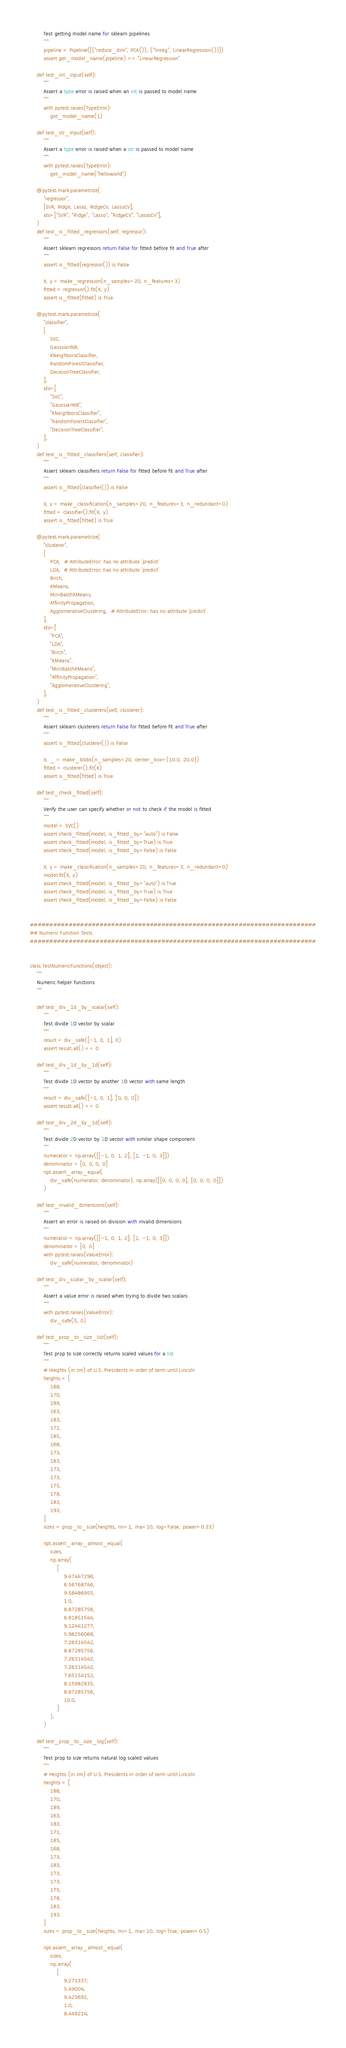<code> <loc_0><loc_0><loc_500><loc_500><_Python_>        Test getting model name for sklearn pipelines
        """
        pipeline = Pipeline([("reduce_dim", PCA()), ("linreg", LinearRegression())])
        assert get_model_name(pipeline) == "LinearRegression"

    def test_int_input(self):
        """
        Assert a type error is raised when an int is passed to model name
        """
        with pytest.raises(TypeError):
            get_model_name(1)

    def test_str_input(self):
        """
        Assert a type error is raised when a str is passed to model name
        """
        with pytest.raises(TypeError):
            get_model_name("helloworld")

    @pytest.mark.parametrize(
        "regressor",
        [SVR, Ridge, Lasso, RidgeCV, LassoCV],
        ids=["SVR", "Ridge", "Lasso", "RidgeCV", "LassoCV"],
    )
    def test_is_fitted_regressors(self, regressor):
        """
        Assert sklearn regressors return False for fitted before fit and True after
        """
        assert is_fitted(regressor()) is False

        X, y = make_regression(n_samples=20, n_features=3)
        fitted = regressor().fit(X, y)
        assert is_fitted(fitted) is True

    @pytest.mark.parametrize(
        "classifier",
        [
            SVC,
            GaussianNB,
            KNeighborsClassifier,
            RandomForestClassifier,
            DecisionTreeClassifier,
        ],
        ids=[
            "SVC",
            "GaussianNB",
            "KNeighborsClassifier",
            "RandomForestClassifier",
            "DecisionTreeClassifier",
        ],
    )
    def test_is_fitted_classifiers(self, classifier):
        """
        Assert sklearn classifiers return False for fitted before fit and True after
        """
        assert is_fitted(classifier()) is False

        X, y = make_classification(n_samples=20, n_features=3, n_redundant=0)
        fitted = classifier().fit(X, y)
        assert is_fitted(fitted) is True

    @pytest.mark.parametrize(
        "clusterer",
        [
            PCA,  # AttributeError: has no attribute 'predict'
            LDA,  # AttributeError: has no attribute 'predict'
            Birch,
            KMeans,
            MiniBatchKMeans,
            AffinityPropagation,
            AgglomerativeClustering,  # AttributeError: has no attribute 'predict'
        ],
        ids=[
            "PCA",
            "LDA",
            "Birch",
            "KMeans",
            "MiniBatchKMeans",
            "AffinityPropagation",
            "AgglomerativeClustering",
        ],
    )
    def test_is_fitted_clusterers(self, clusterer):
        """
        Assert sklearn clusterers return False for fitted before fit and True after
        """
        assert is_fitted(clusterer()) is False

        X, _ = make_blobs(n_samples=20, center_box=(10.0, 20.0))
        fitted = clusterer().fit(X)
        assert is_fitted(fitted) is True

    def test_check_fitted(self):
        """
        Verify the user can specify whether or not to check if the model is fitted
        """
        model = SVC()
        assert check_fitted(model, is_fitted_by="auto") is False
        assert check_fitted(model, is_fitted_by=True) is True
        assert check_fitted(model, is_fitted_by=False) is False

        X, y = make_classification(n_samples=20, n_features=3, n_redundant=0)
        model.fit(X, y)
        assert check_fitted(model, is_fitted_by="auto") is True
        assert check_fitted(model, is_fitted_by=True) is True
        assert check_fitted(model, is_fitted_by=False) is False


##########################################################################
## Numeric Function Tests
##########################################################################


class TestNumericFunctions(object):
    """
    Numeric helper functions
    """

    def test_div_1d_by_scalar(self):
        """
        Test divide 1D vector by scalar
        """
        result = div_safe([-1, 0, 1], 0)
        assert result.all() == 0

    def test_div_1d_by_1d(self):
        """
        Test divide 1D vector by another 1D vector with same length
        """
        result = div_safe([-1, 0, 1], [0, 0, 0])
        assert result.all() == 0

    def test_div_2d_by_1d(self):
        """
        Test divide 2D vector by 1D vector with similar shape component
        """
        numerator = np.array([[-1, 0, 1, 2], [1, -1, 0, 3]])
        denominator = [0, 0, 0, 0]
        npt.assert_array_equal(
            div_safe(numerator, denominator), np.array([[0, 0, 0, 0], [0, 0, 0, 0]])
        )

    def test_invalid_dimensions(self):
        """
        Assert an error is raised on division with invalid dimensions
        """
        numerator = np.array([[-1, 0, 1, 2], [1, -1, 0, 3]])
        denominator = [0, 0]
        with pytest.raises(ValueError):
            div_safe(numerator, denominator)

    def test_div_scalar_by_scalar(self):
        """
        Assert a value error is raised when trying to divide two scalars
        """
        with pytest.raises(ValueError):
            div_safe(5, 0)

    def test_prop_to_size_list(self):
        """
        Test prop to size correctly returns scaled values for a list
        """
        # Hieghts (in cm) of U.S. Presidents in order of term until Lincoln
        heights = [
            188,
            170,
            189,
            163,
            183,
            171,
            185,
            168,
            173,
            183,
            173,
            173,
            175,
            178,
            183,
            193,
        ]
        sizes = prop_to_size(heights, mi=1, ma=10, log=False, power=0.33)

        npt.assert_array_almost_equal(
            sizes,
            np.array(
                [
                    9.47447296,
                    6.56768746,
                    9.58486955,
                    1.0,
                    8.87285756,
                    6.81851544,
                    9.12441277,
                    5.98256068,
                    7.26314542,
                    8.87285756,
                    7.26314542,
                    7.26314542,
                    7.65154152,
                    8.15982835,
                    8.87285756,
                    10.0,
                ]
            ),
        )

    def test_prop_to_size_log(self):
        """
        Test prop to size returns natural log scaled values
        """
        # Heights (in cm) of U.S. Presidents in order of term until Lincoln
        heights = [
            188,
            170,
            189,
            163,
            183,
            171,
            185,
            168,
            173,
            183,
            173,
            173,
            175,
            178,
            183,
            193,
        ]
        sizes = prop_to_size(heights, mi=1, ma=10, log=True, power=0.5)

        npt.assert_array_almost_equal(
            sizes,
            np.array(
                [
                    9.271337,
                    5.49004,
                    9.423692,
                    1.0,
                    8.449214,</code> 